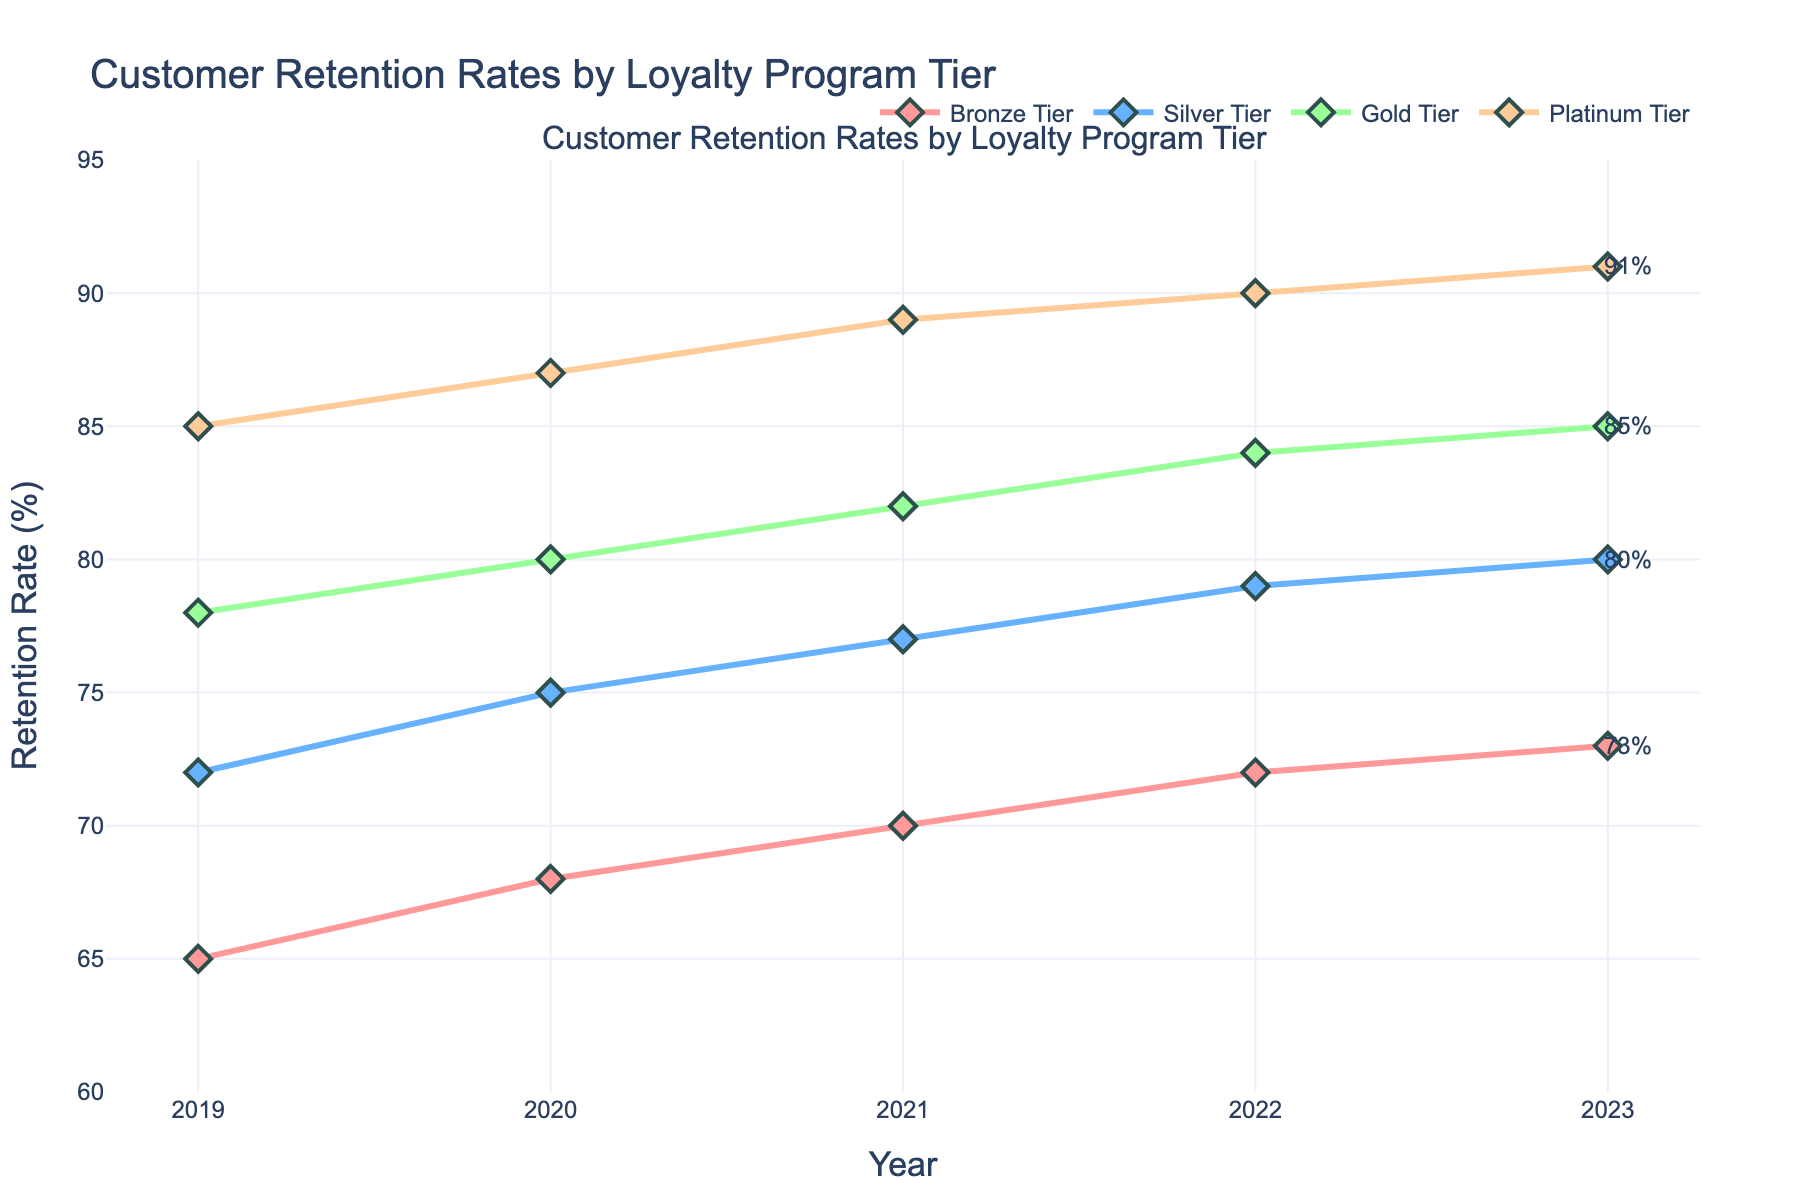What is the overall trend in retention rates for the Bronze Tier from 2019 to 2023? The trend shows the retention rate for the Bronze Tier increasing yearly: from 65% in 2019 to 73% in 2023.
Answer: Increasing Which loyalty program tier had the highest retention rate in 2022? Looking at the highest point for the year 2022, the Platinum Tier had the highest retention rate at 90%.
Answer: Platinum Tier What is the average retention rate for the Silver Tier across all years? Summing the retention rates for the Silver Tier: 72 + 75 + 77 + 79 + 80 = 383. Dividing by 5 (the number of years) gives an average of 76.6%.
Answer: 76.6% What is the difference in retention rates between the Gold Tier in 2023 and the Bronze Tier in 2019? In 2023, the Gold Tier retention rate is 85%, and in 2019, the Bronze Tier retention rate is 65%. Difference: 85 - 65 = 20%.
Answer: 20% Between which two consecutive years did the Silver Tier see the largest increase in retention rate? Calculating the differences: 
<2019 to 2020: 75 - 72 = 3> 
<2020 to 2021: 77 - 75 = 2> 
<2021 to 2022: 79 - 77 = 2> 
<2022 to 2023: 80 - 79 = 1>. 
The largest increase of 3% happened between 2019 and 2020.
Answer: 2019 to 2020 How much did the retention rate for the Platinum Tier change from 2019 to 2021? The retention rate for the Platinum Tier was 85% in 2019 and 89% in 2021. The change is 89 - 85 = 4%.
Answer: 4% Among all tiers in 2023, which one had the lowest retention rate? In 2023, the Bronze Tier had the lowest retention rate at 73%.
Answer: Bronze Tier What is the average yearly increase in retention rates for the Gold Tier from 2019 to 2023? Summing yearly increases: 
<2020 - 2019: 80 - 78 = 2> 
<2021 - 2020: 82 - 80 = 2> 
<2022 - 2021: 84 - 82 = 2> 
<2023 - 2022: 85 - 84 = 1>. 
Sum = 2 + 2 + 2 + 1 = 7. Average = 7 / 4 = 1.75%.
Answer: 1.75% Which tier had the smallest total increase in retention rates over the years and what was the amount? Calculating the total increase for each tier from 2019 to 2023:
< Bronze Tier: 73 - 65 = 8>
< Silver Tier: 80 - 72 = 8>
< Gold Tier: 85 - 78 = 7>
< Platinum Tier: 91 - 85 = 6>.
The Platinum Tier had the smallest increase of 6%.
Answer: Platinum Tier, 6% How much higher was the retention rate of the Platinum Tier compared to the Bronze Tier in 2020? In 2020, the retention rate for Platinum Tier was 87% and for Bronze Tier was 68%. The difference is 87 - 68 = 19%.
Answer: 19% 